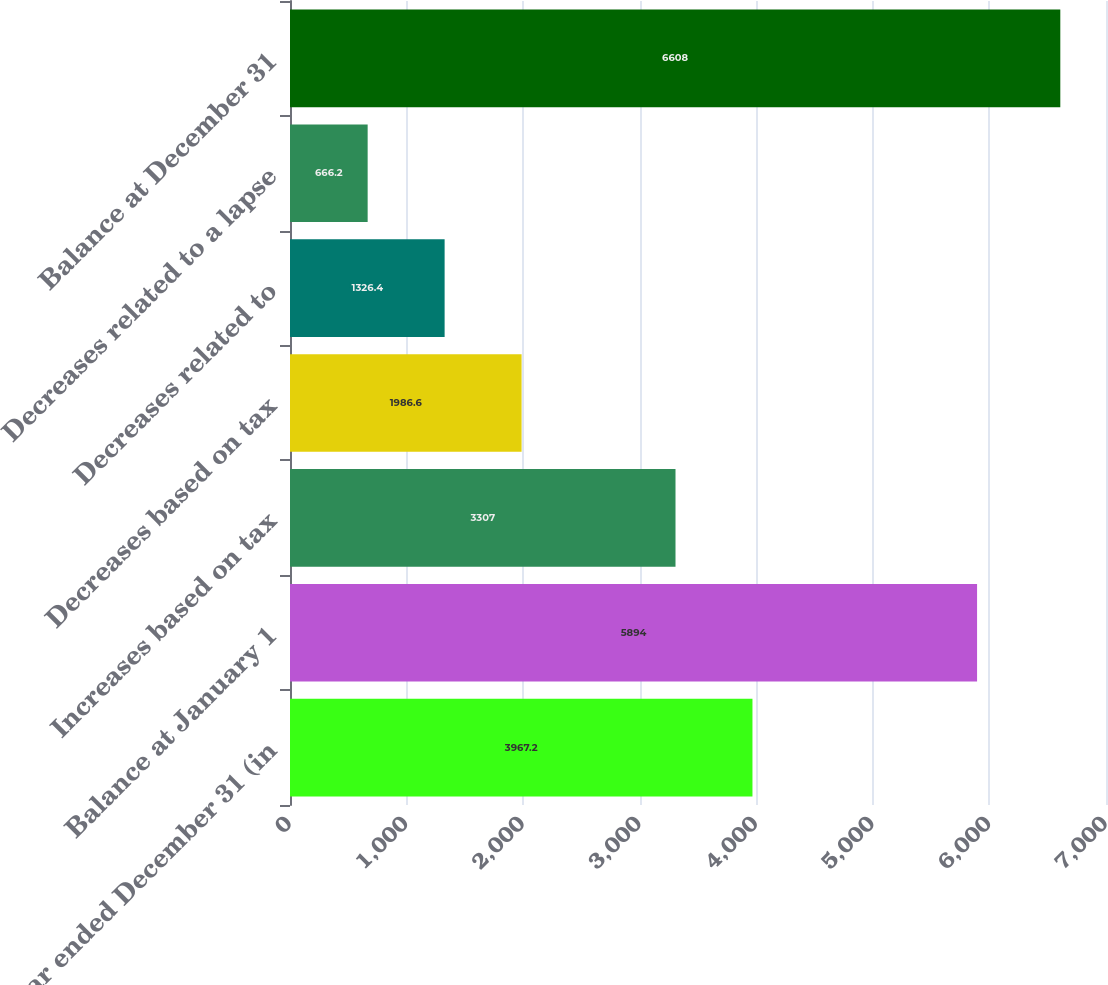Convert chart to OTSL. <chart><loc_0><loc_0><loc_500><loc_500><bar_chart><fcel>Year ended December 31 (in<fcel>Balance at January 1<fcel>Increases based on tax<fcel>Decreases based on tax<fcel>Decreases related to<fcel>Decreases related to a lapse<fcel>Balance at December 31<nl><fcel>3967.2<fcel>5894<fcel>3307<fcel>1986.6<fcel>1326.4<fcel>666.2<fcel>6608<nl></chart> 